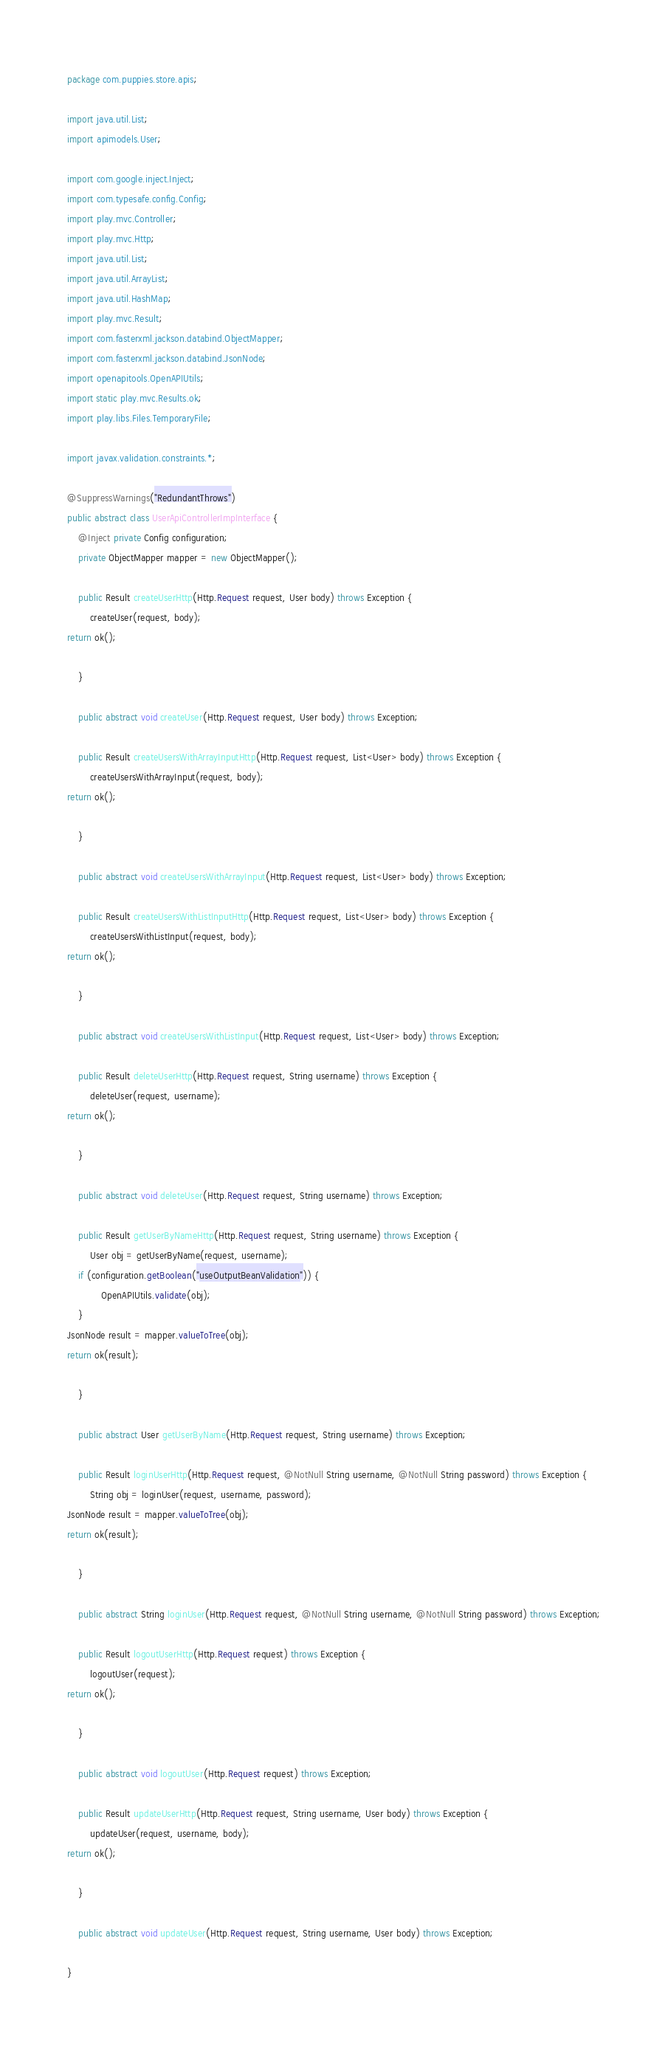<code> <loc_0><loc_0><loc_500><loc_500><_Java_>package com.puppies.store.apis;

import java.util.List;
import apimodels.User;

import com.google.inject.Inject;
import com.typesafe.config.Config;
import play.mvc.Controller;
import play.mvc.Http;
import java.util.List;
import java.util.ArrayList;
import java.util.HashMap;
import play.mvc.Result;
import com.fasterxml.jackson.databind.ObjectMapper;
import com.fasterxml.jackson.databind.JsonNode;
import openapitools.OpenAPIUtils;
import static play.mvc.Results.ok;
import play.libs.Files.TemporaryFile;

import javax.validation.constraints.*;

@SuppressWarnings("RedundantThrows")
public abstract class UserApiControllerImpInterface {
    @Inject private Config configuration;
    private ObjectMapper mapper = new ObjectMapper();

    public Result createUserHttp(Http.Request request, User body) throws Exception {
        createUser(request, body);
return ok();

    }

    public abstract void createUser(Http.Request request, User body) throws Exception;

    public Result createUsersWithArrayInputHttp(Http.Request request, List<User> body) throws Exception {
        createUsersWithArrayInput(request, body);
return ok();

    }

    public abstract void createUsersWithArrayInput(Http.Request request, List<User> body) throws Exception;

    public Result createUsersWithListInputHttp(Http.Request request, List<User> body) throws Exception {
        createUsersWithListInput(request, body);
return ok();

    }

    public abstract void createUsersWithListInput(Http.Request request, List<User> body) throws Exception;

    public Result deleteUserHttp(Http.Request request, String username) throws Exception {
        deleteUser(request, username);
return ok();

    }

    public abstract void deleteUser(Http.Request request, String username) throws Exception;

    public Result getUserByNameHttp(Http.Request request, String username) throws Exception {
        User obj = getUserByName(request, username);
    if (configuration.getBoolean("useOutputBeanValidation")) {
            OpenAPIUtils.validate(obj);
    }
JsonNode result = mapper.valueToTree(obj);
return ok(result);

    }

    public abstract User getUserByName(Http.Request request, String username) throws Exception;

    public Result loginUserHttp(Http.Request request, @NotNull String username, @NotNull String password) throws Exception {
        String obj = loginUser(request, username, password);
JsonNode result = mapper.valueToTree(obj);
return ok(result);

    }

    public abstract String loginUser(Http.Request request, @NotNull String username, @NotNull String password) throws Exception;

    public Result logoutUserHttp(Http.Request request) throws Exception {
        logoutUser(request);
return ok();

    }

    public abstract void logoutUser(Http.Request request) throws Exception;

    public Result updateUserHttp(Http.Request request, String username, User body) throws Exception {
        updateUser(request, username, body);
return ok();

    }

    public abstract void updateUser(Http.Request request, String username, User body) throws Exception;

}
</code> 